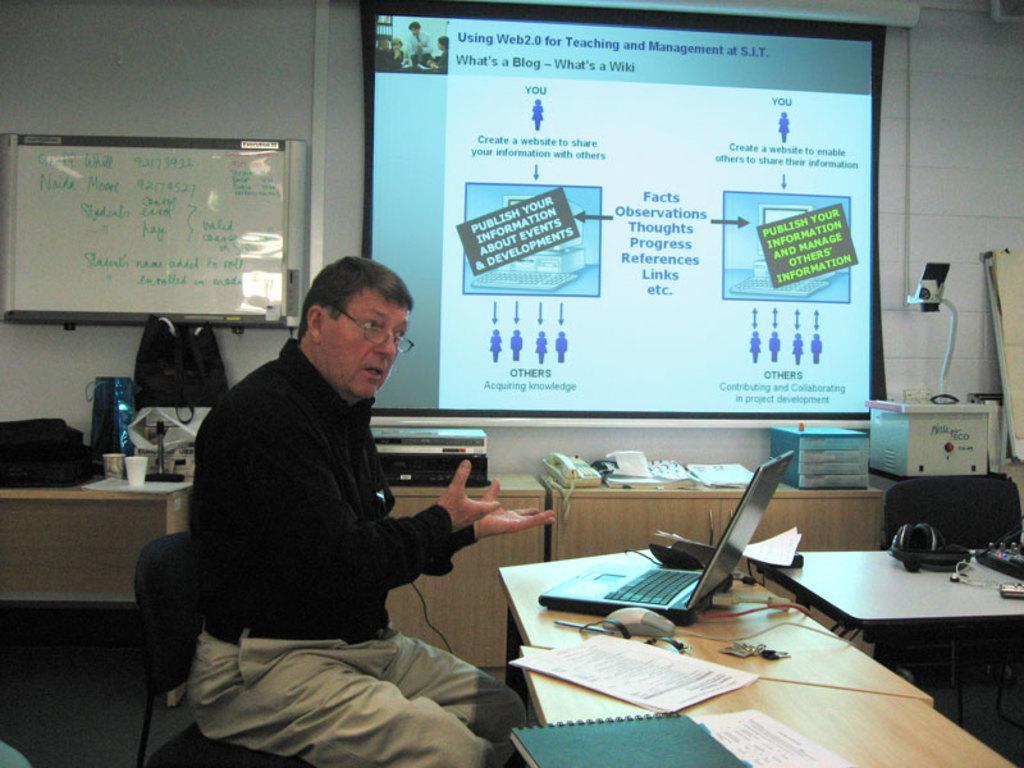Could you give a brief overview of what you see in this image? In this image, we can see a person sitting on the chair and wearing glasses. In the background, there is a laptop, papers, a book and some other objects on the tables and there is an other chair and we can see a screen and a board on the wall and there is some text on them and there are bags, cups, a telephone and some other objects on the stands. At the bottom, there is a floor. 